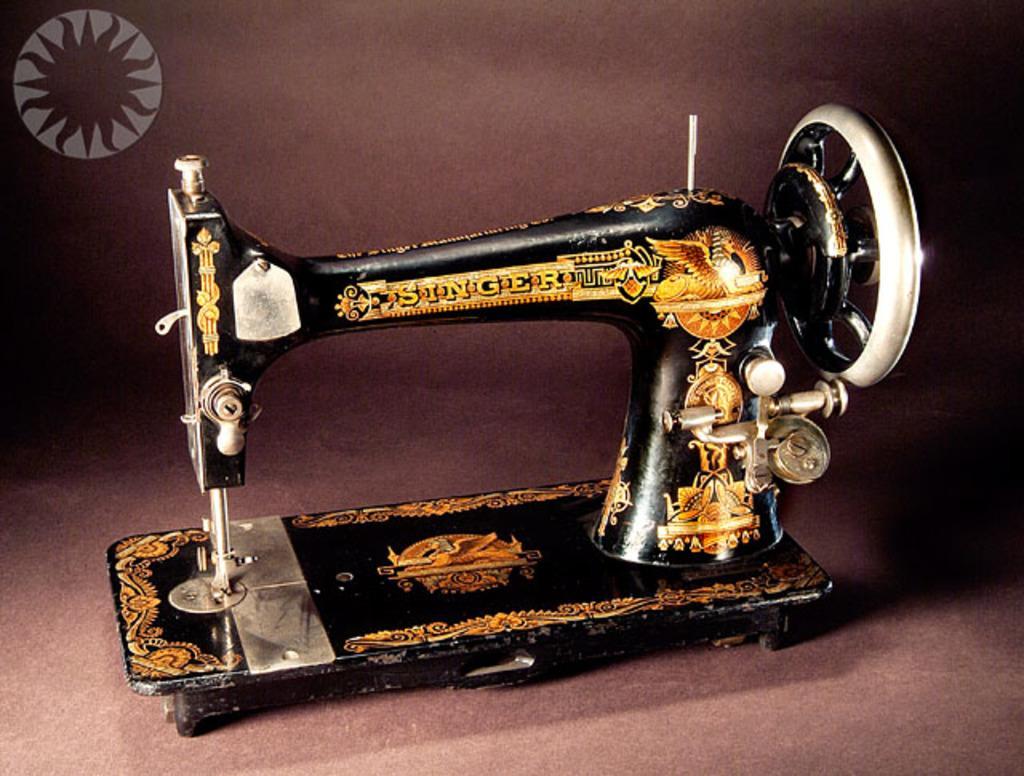How would you summarize this image in a sentence or two? In this image I can see the sewing machine in black and gold color and the background is in brown color. 